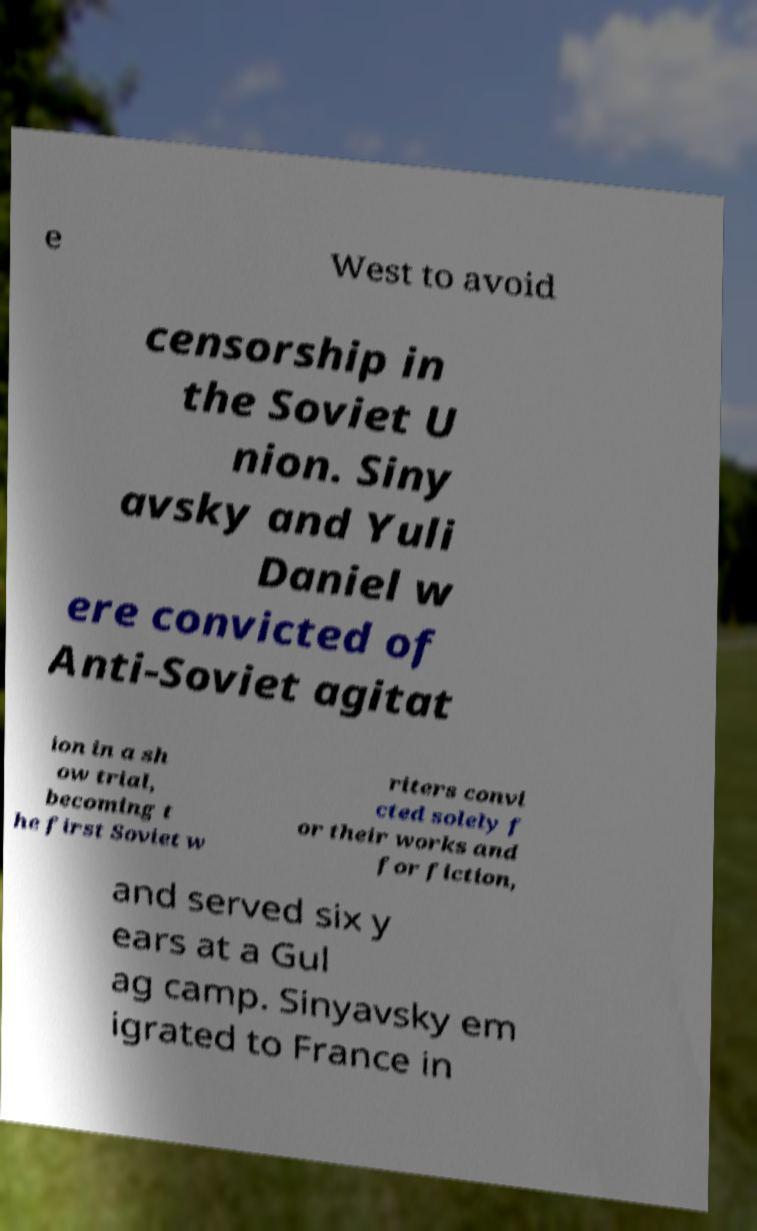Please identify and transcribe the text found in this image. e West to avoid censorship in the Soviet U nion. Siny avsky and Yuli Daniel w ere convicted of Anti-Soviet agitat ion in a sh ow trial, becoming t he first Soviet w riters convi cted solely f or their works and for fiction, and served six y ears at a Gul ag camp. Sinyavsky em igrated to France in 